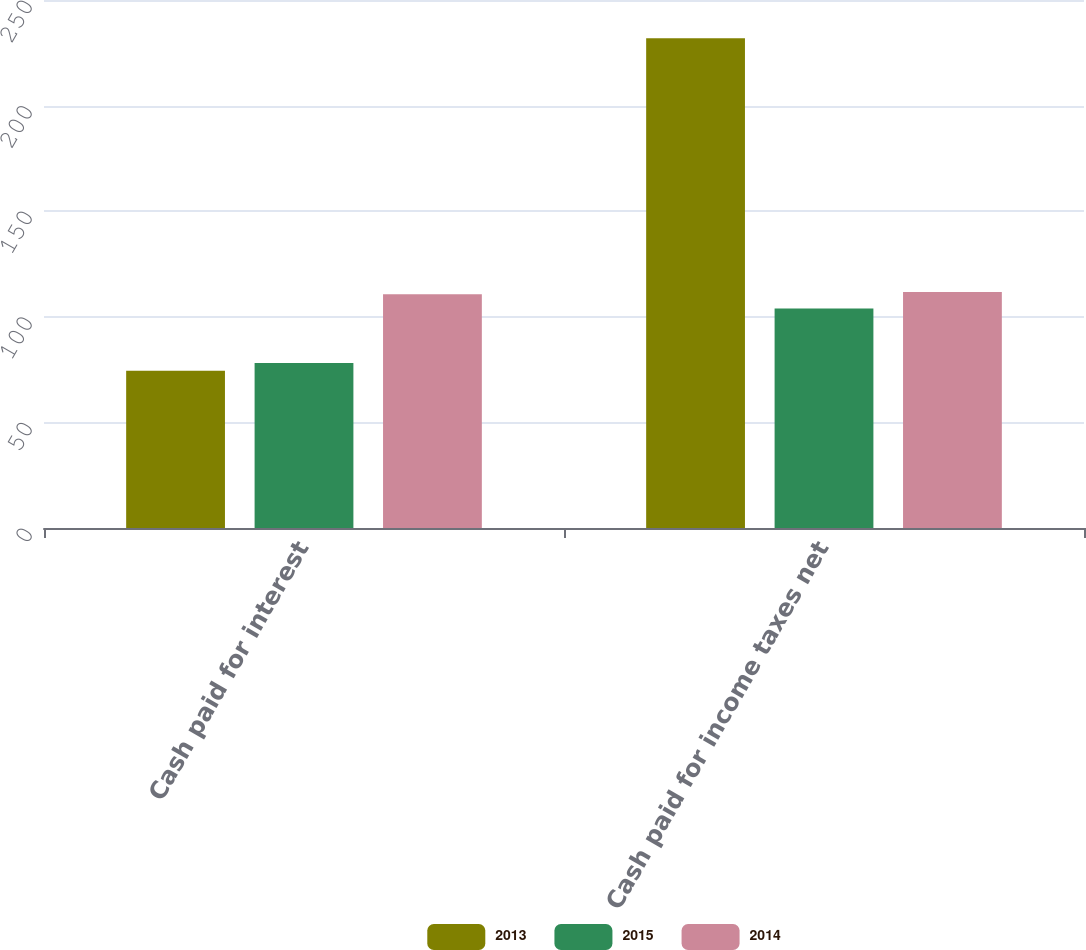Convert chart. <chart><loc_0><loc_0><loc_500><loc_500><stacked_bar_chart><ecel><fcel>Cash paid for interest<fcel>Cash paid for income taxes net<nl><fcel>2013<fcel>74.5<fcel>231.9<nl><fcel>2015<fcel>78.1<fcel>103.9<nl><fcel>2014<fcel>110.7<fcel>111.8<nl></chart> 